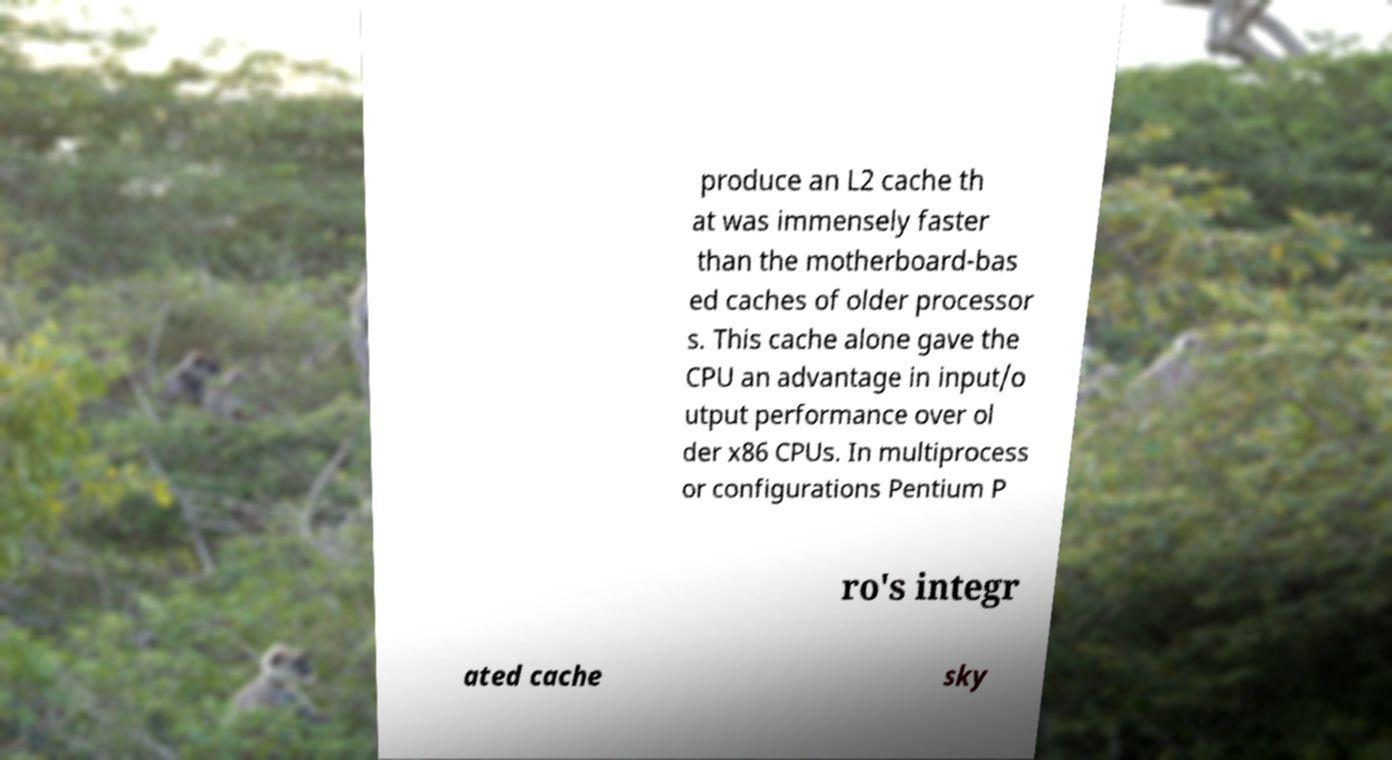For documentation purposes, I need the text within this image transcribed. Could you provide that? produce an L2 cache th at was immensely faster than the motherboard-bas ed caches of older processor s. This cache alone gave the CPU an advantage in input/o utput performance over ol der x86 CPUs. In multiprocess or configurations Pentium P ro's integr ated cache sky 